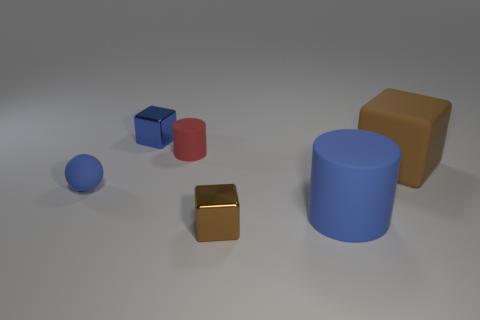Add 1 small matte cylinders. How many objects exist? 7 Subtract all balls. How many objects are left? 5 Subtract 0 green cubes. How many objects are left? 6 Subtract all small cyan metal things. Subtract all big things. How many objects are left? 4 Add 5 large blocks. How many large blocks are left? 6 Add 2 blue rubber things. How many blue rubber things exist? 4 